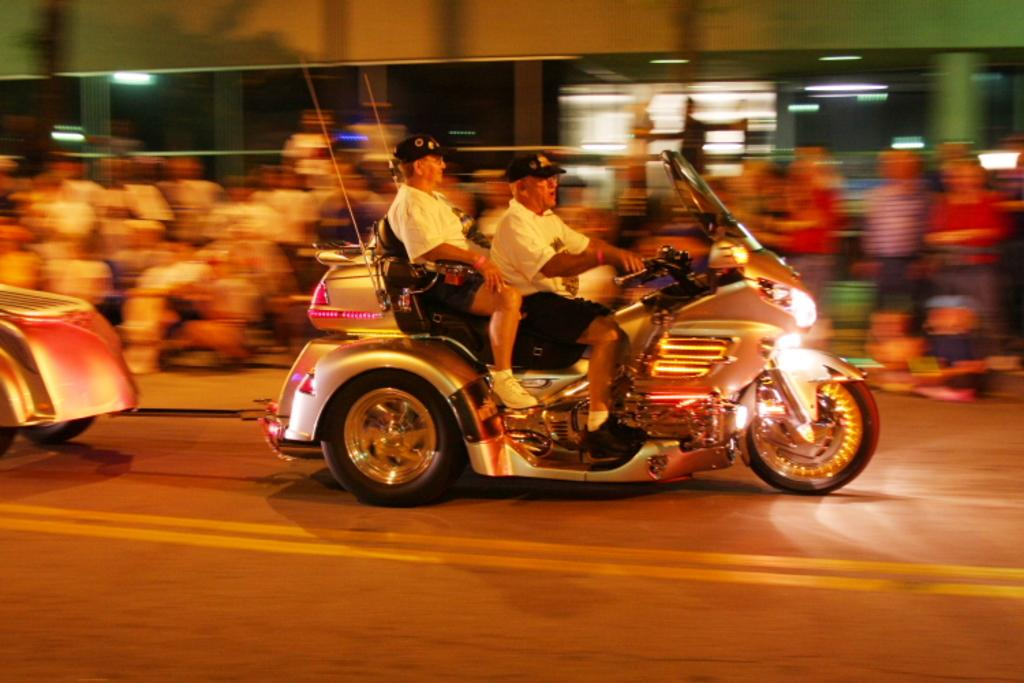What is the main subject of the image? The main subject of the image is a man riding a bike. What is the man wearing in the image? The man is wearing a cap and spectacles in the image. Who else is present in the image? There is another person sitting behind the man on the bike, and a group of people is also present. What are the group of people doing in the image? The group of people is looking at the man riding the bike. How is the image of the group of people? The image of the group of people is blurry. What type of board can be seen in the image? There is no board present in the image. How many mice are visible in the image? There are no mice visible in the image. 